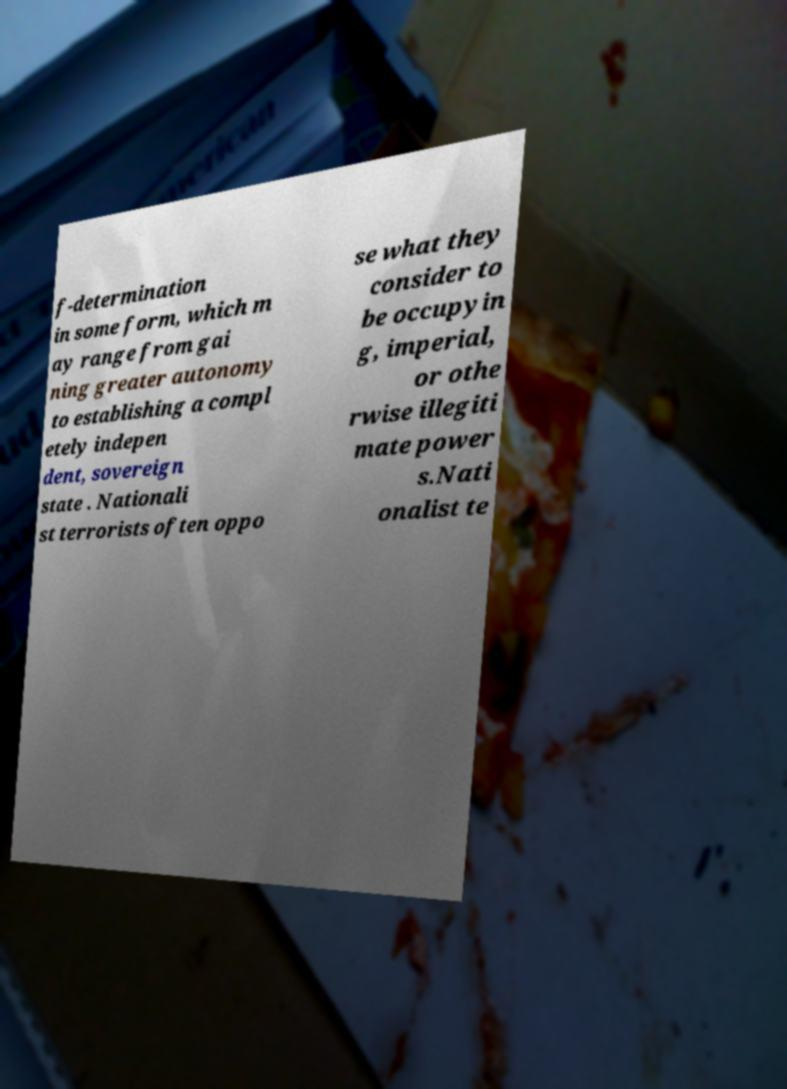There's text embedded in this image that I need extracted. Can you transcribe it verbatim? f-determination in some form, which m ay range from gai ning greater autonomy to establishing a compl etely indepen dent, sovereign state . Nationali st terrorists often oppo se what they consider to be occupyin g, imperial, or othe rwise illegiti mate power s.Nati onalist te 